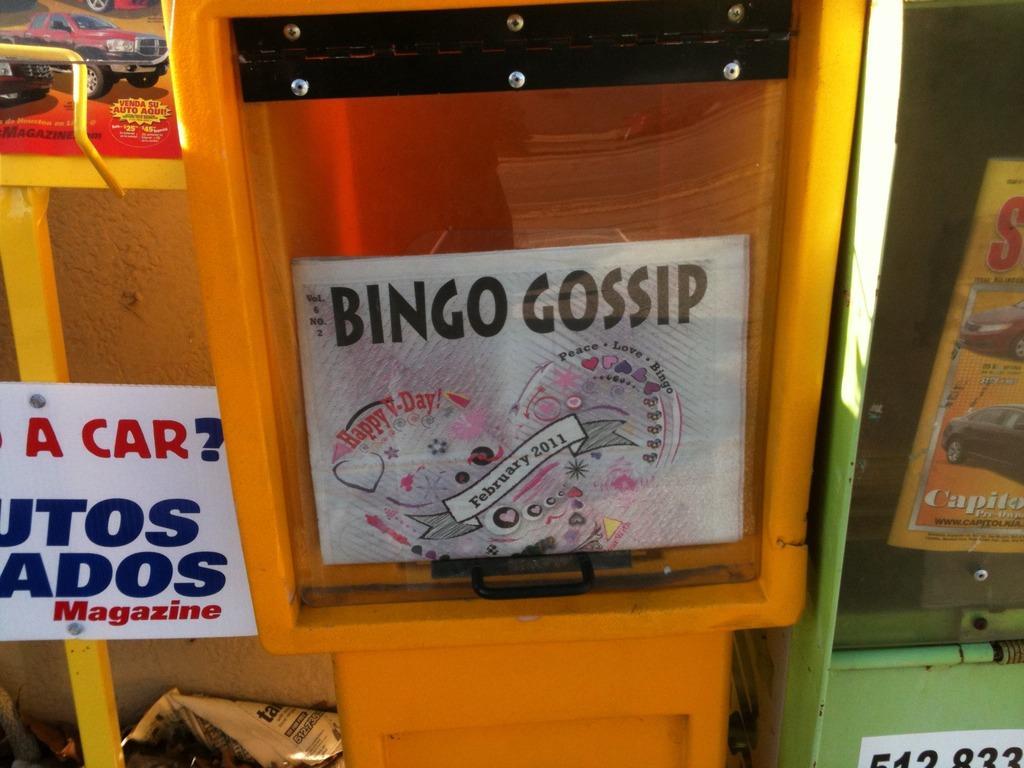Describe this image in one or two sentences. In this image we can see a board on which some text is written, posters and papers are there. 